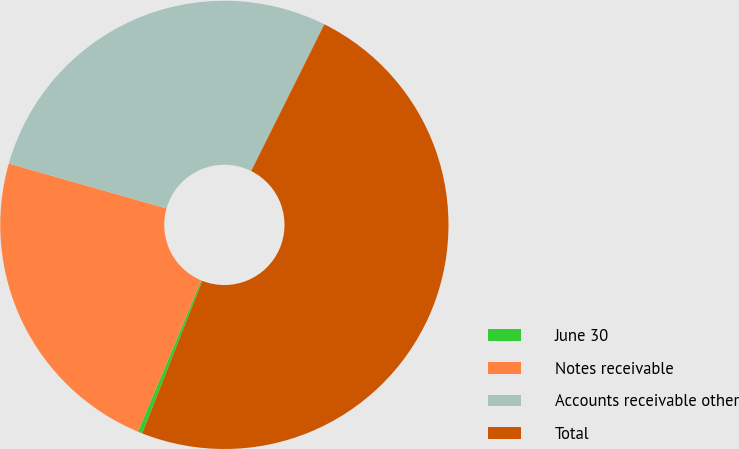Convert chart. <chart><loc_0><loc_0><loc_500><loc_500><pie_chart><fcel>June 30<fcel>Notes receivable<fcel>Accounts receivable other<fcel>Total<nl><fcel>0.32%<fcel>23.12%<fcel>27.95%<fcel>48.62%<nl></chart> 